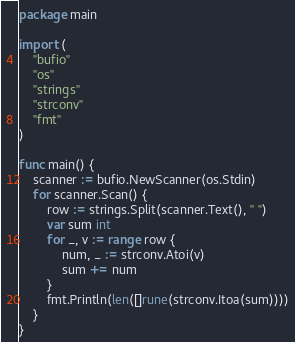<code> <loc_0><loc_0><loc_500><loc_500><_Go_>package main

import (
	"bufio"
	"os"
	"strings"
	"strconv"
	"fmt"
)

func main() {
	scanner := bufio.NewScanner(os.Stdin)
	for scanner.Scan() {
		row := strings.Split(scanner.Text(), " ")
		var sum int
		for _, v := range row {
			num, _ := strconv.Atoi(v)
			sum += num
		}
		fmt.Println(len([]rune(strconv.Itoa(sum))))
	}
}
</code> 